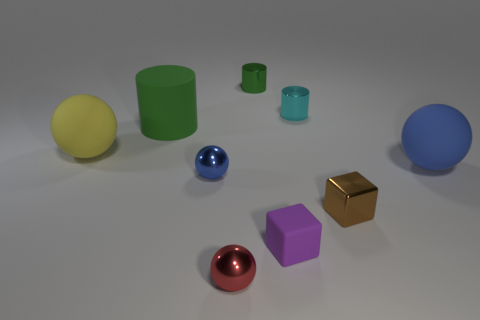Subtract all blue matte spheres. How many spheres are left? 3 Subtract all purple cubes. How many cubes are left? 1 Subtract all brown spheres. How many green cylinders are left? 2 Subtract all cylinders. How many objects are left? 6 Subtract 3 spheres. How many spheres are left? 1 Add 2 blue shiny balls. How many blue shiny balls exist? 3 Subtract 1 purple blocks. How many objects are left? 8 Subtract all brown balls. Subtract all purple cylinders. How many balls are left? 4 Subtract all cyan objects. Subtract all small green objects. How many objects are left? 7 Add 6 purple matte blocks. How many purple matte blocks are left? 7 